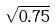<formula> <loc_0><loc_0><loc_500><loc_500>\sqrt { 0 . 7 5 }</formula> 